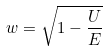Convert formula to latex. <formula><loc_0><loc_0><loc_500><loc_500>w = \sqrt { 1 - \frac { U } { E } }</formula> 